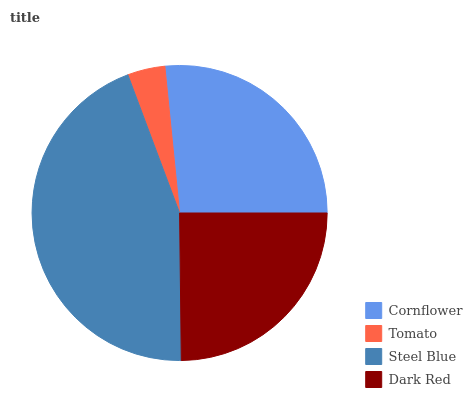Is Tomato the minimum?
Answer yes or no. Yes. Is Steel Blue the maximum?
Answer yes or no. Yes. Is Steel Blue the minimum?
Answer yes or no. No. Is Tomato the maximum?
Answer yes or no. No. Is Steel Blue greater than Tomato?
Answer yes or no. Yes. Is Tomato less than Steel Blue?
Answer yes or no. Yes. Is Tomato greater than Steel Blue?
Answer yes or no. No. Is Steel Blue less than Tomato?
Answer yes or no. No. Is Cornflower the high median?
Answer yes or no. Yes. Is Dark Red the low median?
Answer yes or no. Yes. Is Tomato the high median?
Answer yes or no. No. Is Cornflower the low median?
Answer yes or no. No. 